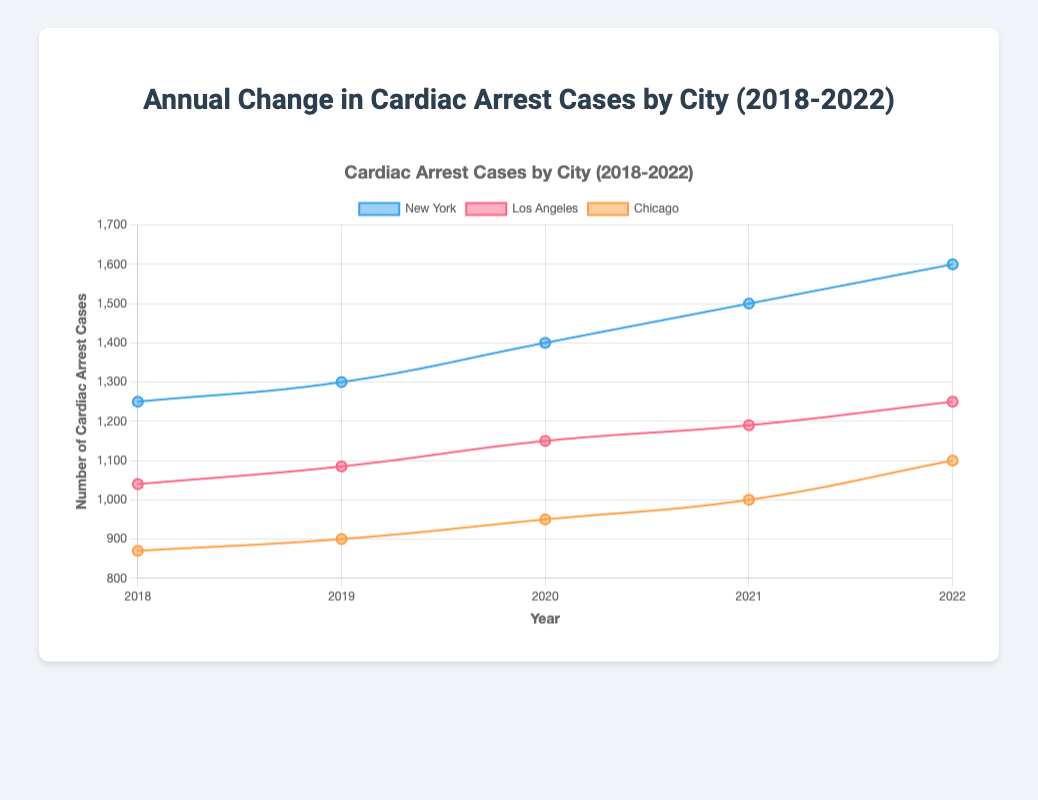What is the general trend in cardiac arrest cases in New York from 2018 to 2022? Observing the line representing New York, the cardiac arrest cases increase each year from 1250 in 2018 to 1600 in 2022.
Answer: Increasing trend How does the number of cardiac arrest cases in Chicago compare between 2018 and 2022? Analyze the Chicago line to note the number of cases in both 2018 (870) and 2022 (1100). The number increases from 870 to 1100 over these years.
Answer: Increased Which city had the highest number of cardiac arrest cases in 2020? Refer to the data points for each city in 2020. New York has the highest value with 1400 cases.
Answer: New York What is the difference in cardiac arrest cases between Los Angeles and Chicago in 2022? Look at the data points for both cities in 2022: Los Angeles (1250) and Chicago (1100). The difference is 1250 - 1100.
Answer: 150 Calculate the average number of cardiac arrest cases in Los Angeles over the five-year period. Sum the cardiac arrest cases in Los Angeles for each year (1040, 1085, 1150, 1190, 1250) and divide by 5. (1040 + 1085 + 1150 + 1190 + 1250) / 5 = 5715 / 5 = 1143
Answer: 1143 Which city experienced the largest absolute increase in cardiac arrest cases from 2018 to 2022? Compare the increases for each city: New York (1600 - 1250 = 350), Los Angeles (1250 - 1040 = 210), Chicago (1100 - 870 = 230). New York has the largest increase.
Answer: New York How do the trends in cardiac arrest cases in Los Angeles and Chicago compare? Both cities show an overall increasing trend, but Los Angeles has a smoother increase, while Chicago’s increase is more gradual and less pronounced.
Answer: Both increasing, LA smoother What was the average number of cardiac arrest cases in New York in 2019 and 2020? Calculate the average of New York’s values for 2019 (1300) and 2020 (1400). (1300 + 1400) / 2 = 2700 / 2 = 1350
Answer: 1350 In which year did Los Angeles and Chicago report the same number of cardiac arrest cases? Check for any overlapping data points. No year reported the same number for both cities.
Answer: None Which city saw the least variation in cardiac arrest cases over the five years? Evaluate the range (max-min) for each city: New York’s range (1600-1250=350), Los Angeles (1250-1040=210), Chicago (1100-870=230). Los Angeles has the least variation.
Answer: Los Angeles 